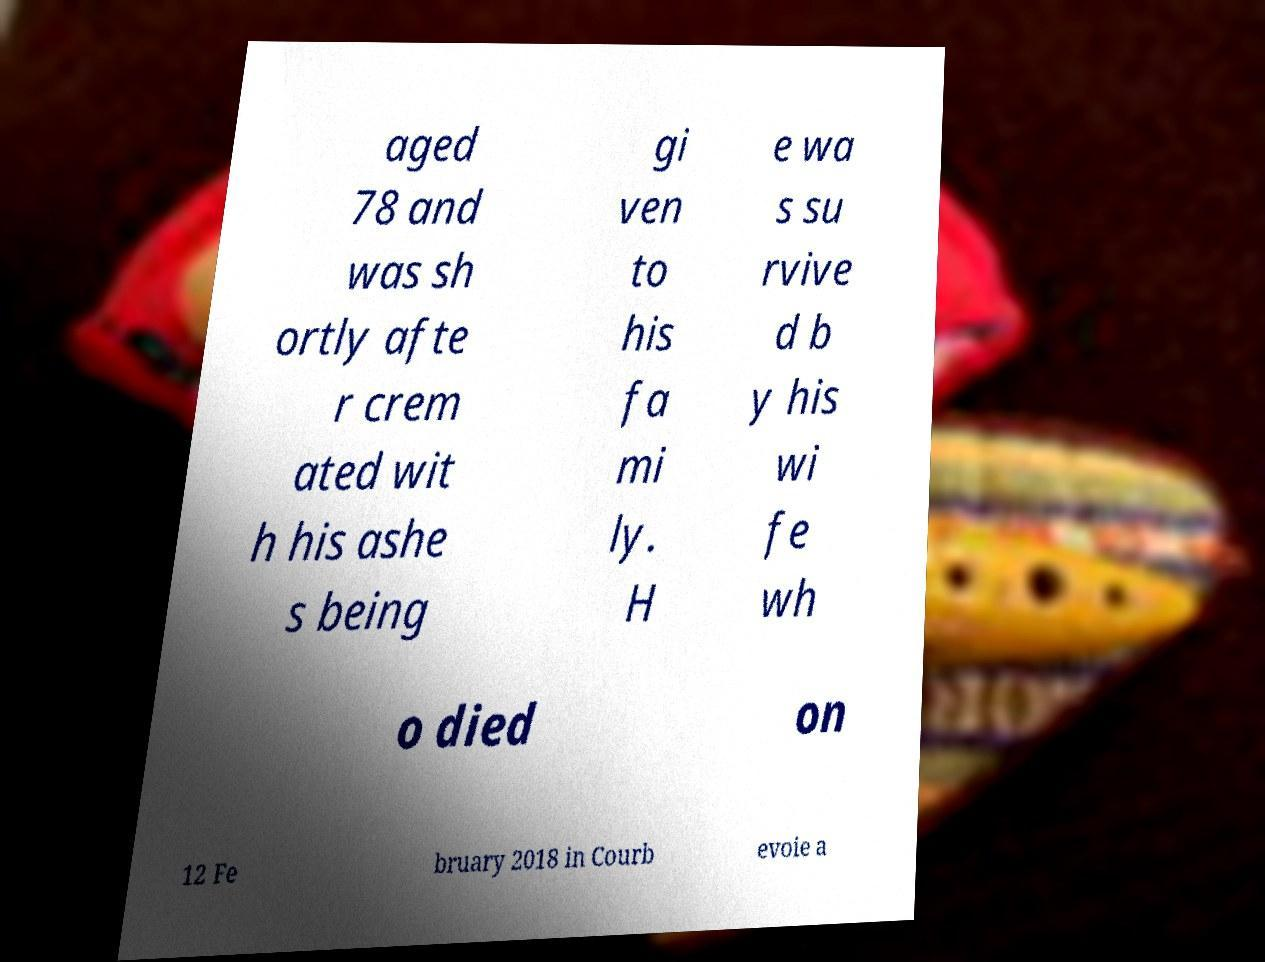Can you accurately transcribe the text from the provided image for me? aged 78 and was sh ortly afte r crem ated wit h his ashe s being gi ven to his fa mi ly. H e wa s su rvive d b y his wi fe wh o died on 12 Fe bruary 2018 in Courb evoie a 